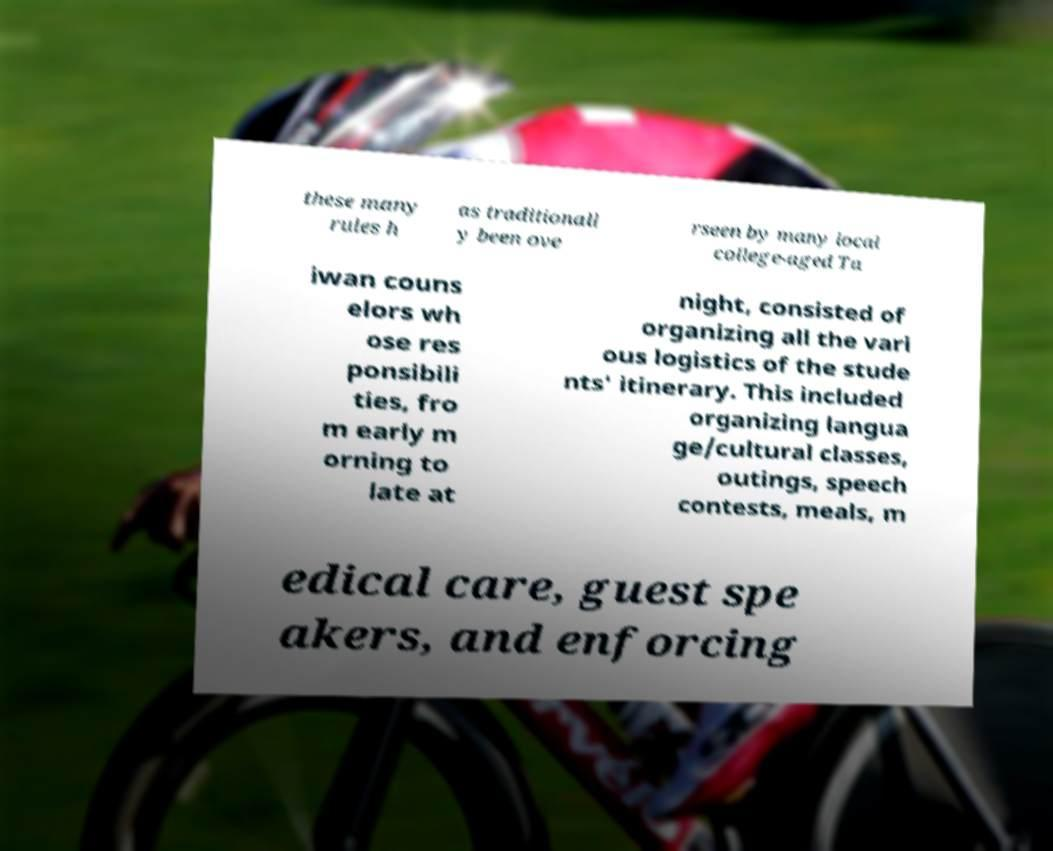There's text embedded in this image that I need extracted. Can you transcribe it verbatim? these many rules h as traditionall y been ove rseen by many local college-aged Ta iwan couns elors wh ose res ponsibili ties, fro m early m orning to late at night, consisted of organizing all the vari ous logistics of the stude nts' itinerary. This included organizing langua ge/cultural classes, outings, speech contests, meals, m edical care, guest spe akers, and enforcing 